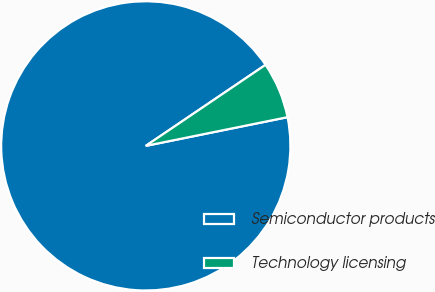Convert chart to OTSL. <chart><loc_0><loc_0><loc_500><loc_500><pie_chart><fcel>Semiconductor products<fcel>Technology licensing<nl><fcel>93.71%<fcel>6.29%<nl></chart> 